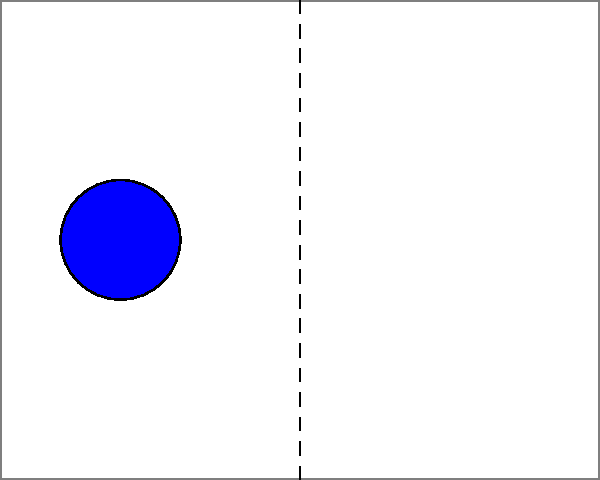In this graphic design layout inspired by the balanced aesthetics often seen in the Obamas' visual branding, which transformation would create perfect symmetry across the vertical axis? To analyze the symmetry in this layout, let's follow these steps:

1. Identify the vertical axis of symmetry: It's the dashed line in the middle of the canvas.

2. Examine the left side of the layout:
   - Circle A: centered at (2,4) with radius 1
   - Rectangle B: positioned at (3,1) to (4,2)

3. Examine the right side of the layout:
   - Circle C: centered at (8,4) with radius 1
   - Rectangle D: positioned at (6,6) to (7,7)

4. Compare the elements on both sides:
   - Circles A and C are symmetrical about the vertical axis
   - Rectangles B and D are not symmetrical

5. To achieve perfect symmetry, we need to move Rectangle D:
   - It should be the mirror image of Rectangle B
   - The correct position would be (6,1) to (7,2)

6. The transformation needed:
   - Translate Rectangle D vertically downward by 5 units

This transformation would create a perfectly symmetrical layout, reminiscent of the balanced designs often associated with the Obamas' visual branding.
Answer: Translate Rectangle D down by 5 units 